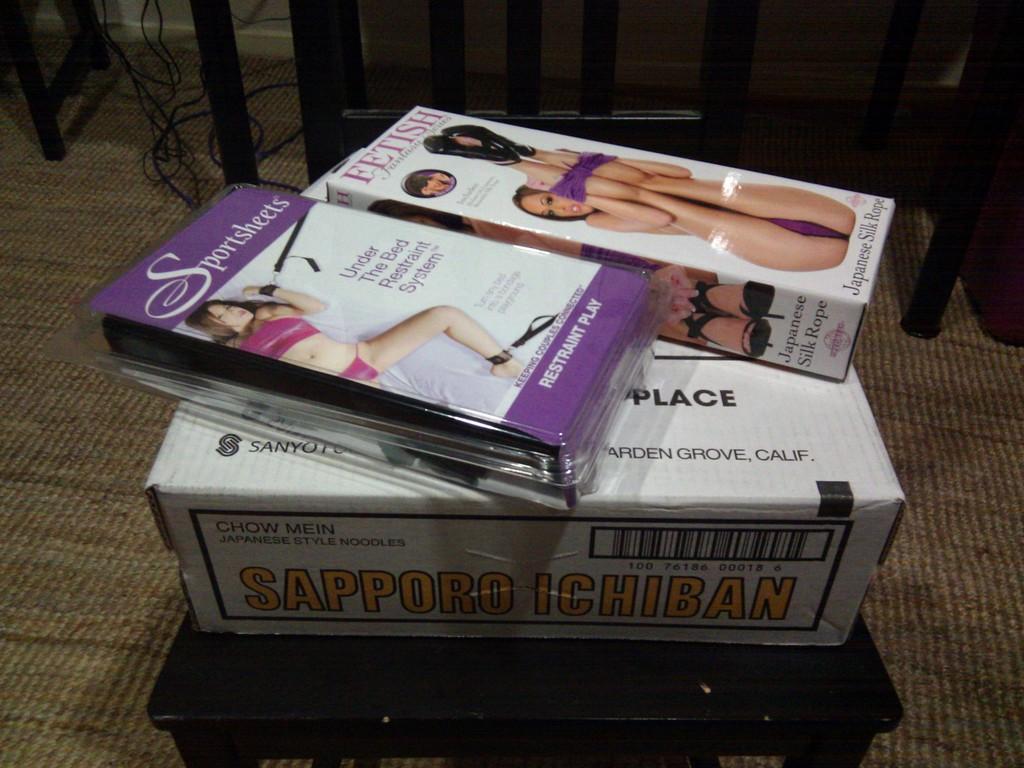Please provide a concise description of this image. In this picture we can see three boxes on a chair, wires and some objects on the floor. 